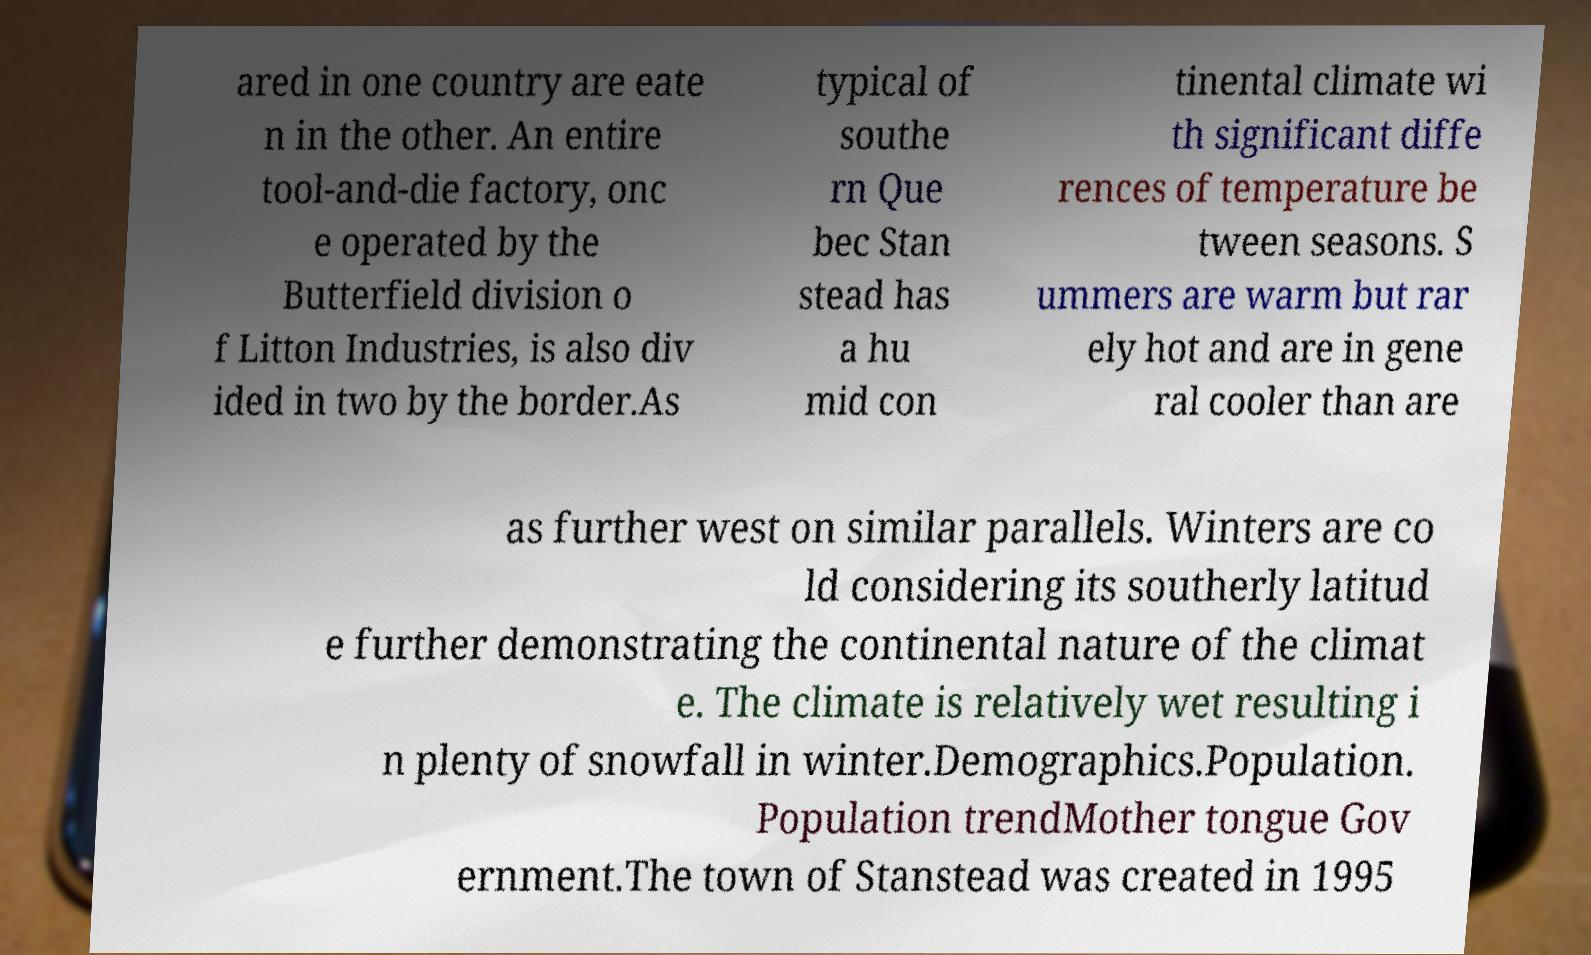For documentation purposes, I need the text within this image transcribed. Could you provide that? ared in one country are eate n in the other. An entire tool-and-die factory, onc e operated by the Butterfield division o f Litton Industries, is also div ided in two by the border.As typical of southe rn Que bec Stan stead has a hu mid con tinental climate wi th significant diffe rences of temperature be tween seasons. S ummers are warm but rar ely hot and are in gene ral cooler than are as further west on similar parallels. Winters are co ld considering its southerly latitud e further demonstrating the continental nature of the climat e. The climate is relatively wet resulting i n plenty of snowfall in winter.Demographics.Population. Population trendMother tongue Gov ernment.The town of Stanstead was created in 1995 